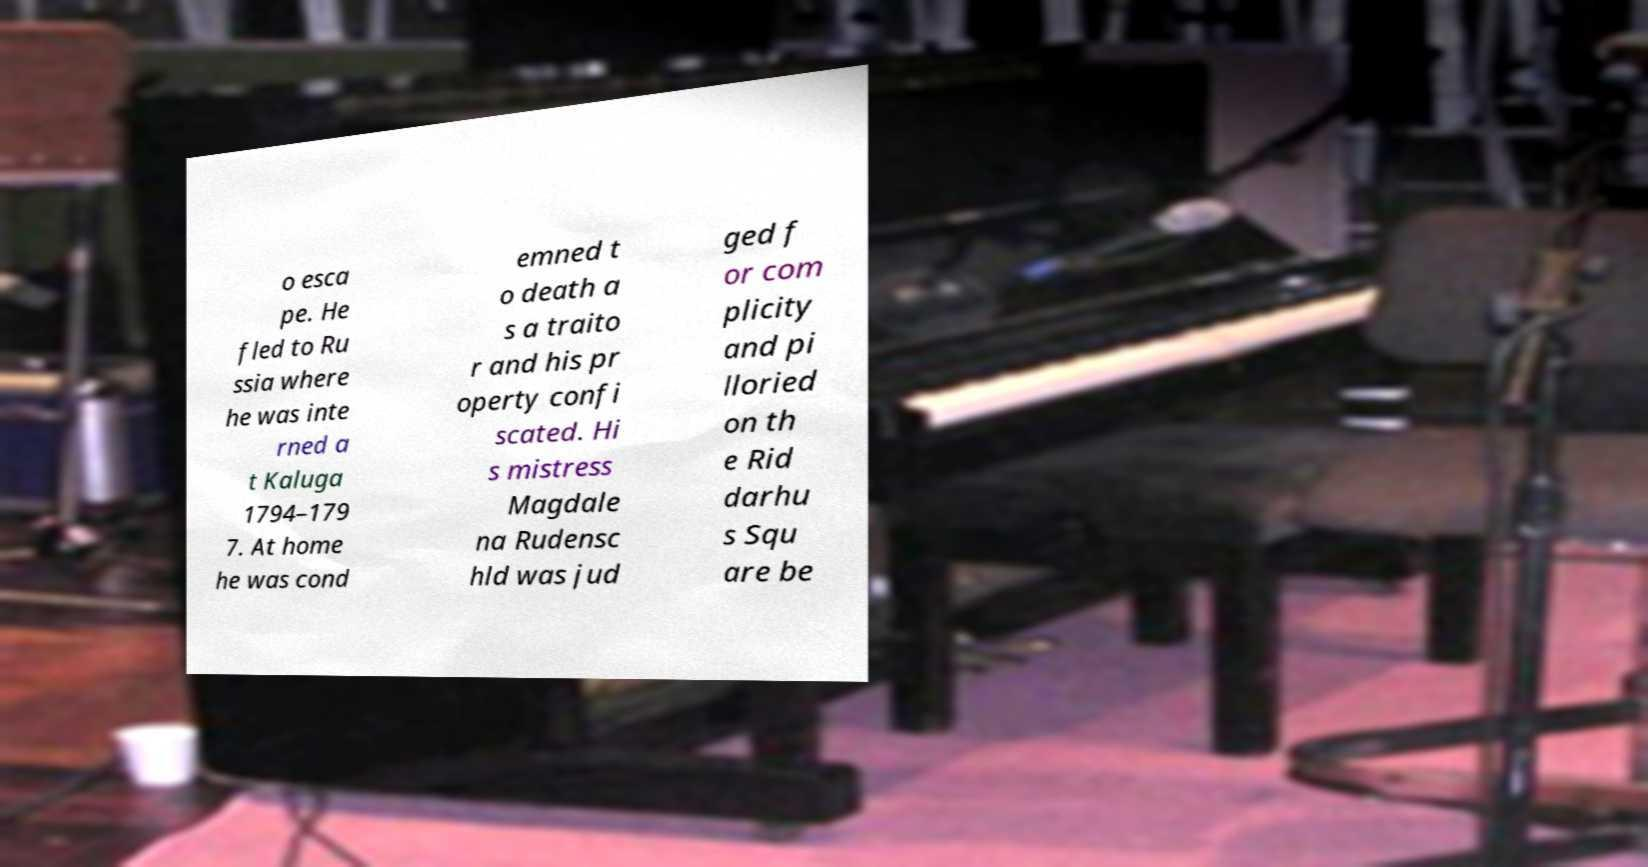I need the written content from this picture converted into text. Can you do that? o esca pe. He fled to Ru ssia where he was inte rned a t Kaluga 1794–179 7. At home he was cond emned t o death a s a traito r and his pr operty confi scated. Hi s mistress Magdale na Rudensc hld was jud ged f or com plicity and pi lloried on th e Rid darhu s Squ are be 